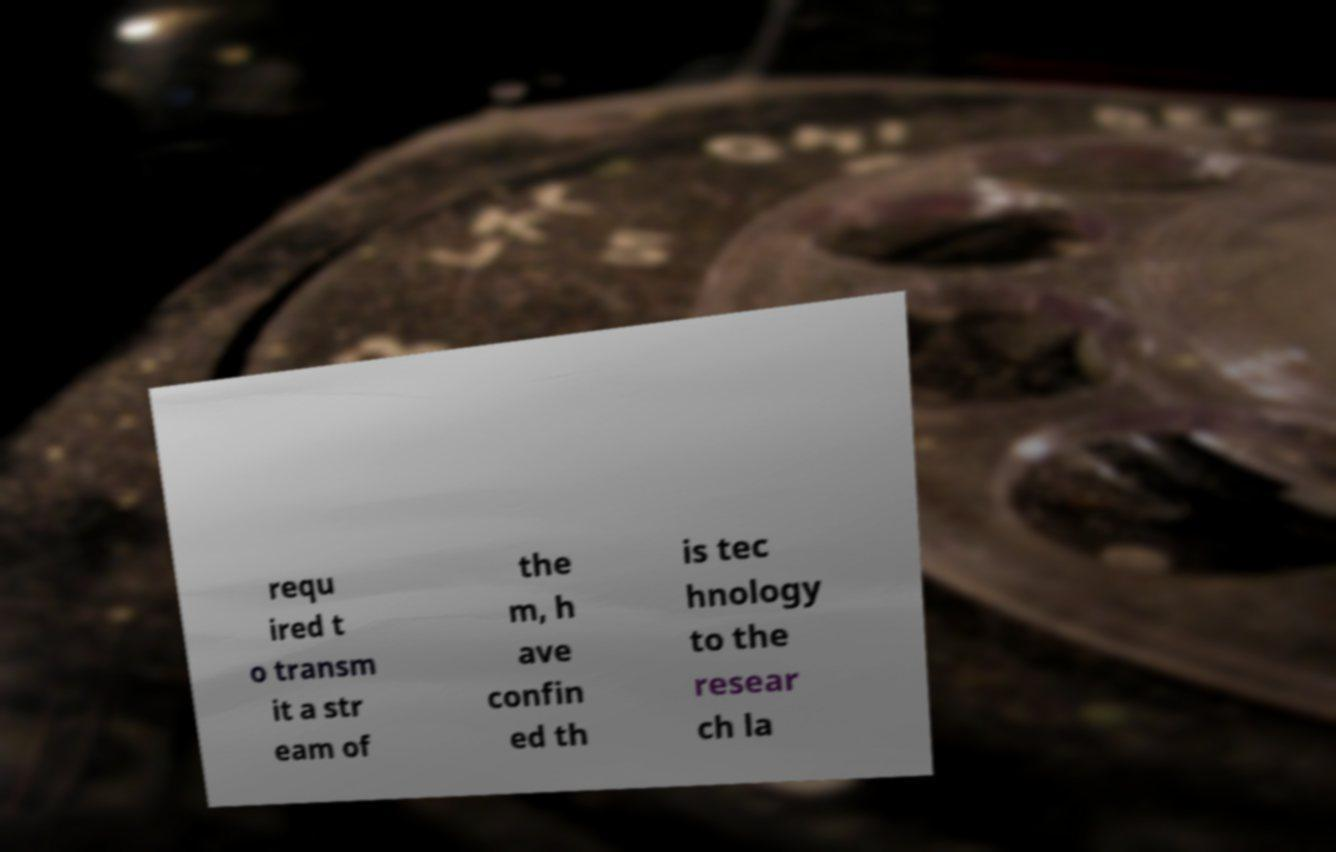Please identify and transcribe the text found in this image. requ ired t o transm it a str eam of the m, h ave confin ed th is tec hnology to the resear ch la 